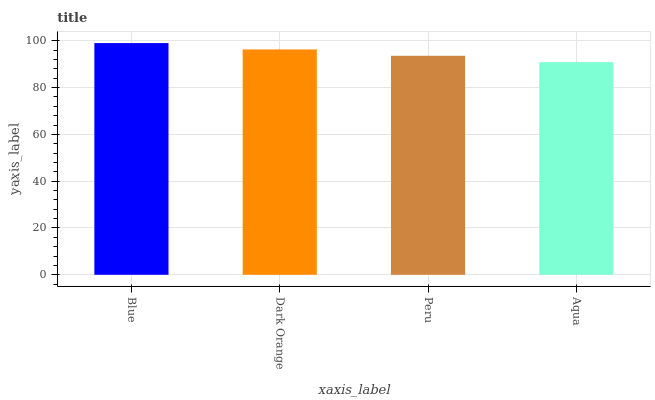Is Aqua the minimum?
Answer yes or no. Yes. Is Blue the maximum?
Answer yes or no. Yes. Is Dark Orange the minimum?
Answer yes or no. No. Is Dark Orange the maximum?
Answer yes or no. No. Is Blue greater than Dark Orange?
Answer yes or no. Yes. Is Dark Orange less than Blue?
Answer yes or no. Yes. Is Dark Orange greater than Blue?
Answer yes or no. No. Is Blue less than Dark Orange?
Answer yes or no. No. Is Dark Orange the high median?
Answer yes or no. Yes. Is Peru the low median?
Answer yes or no. Yes. Is Blue the high median?
Answer yes or no. No. Is Dark Orange the low median?
Answer yes or no. No. 